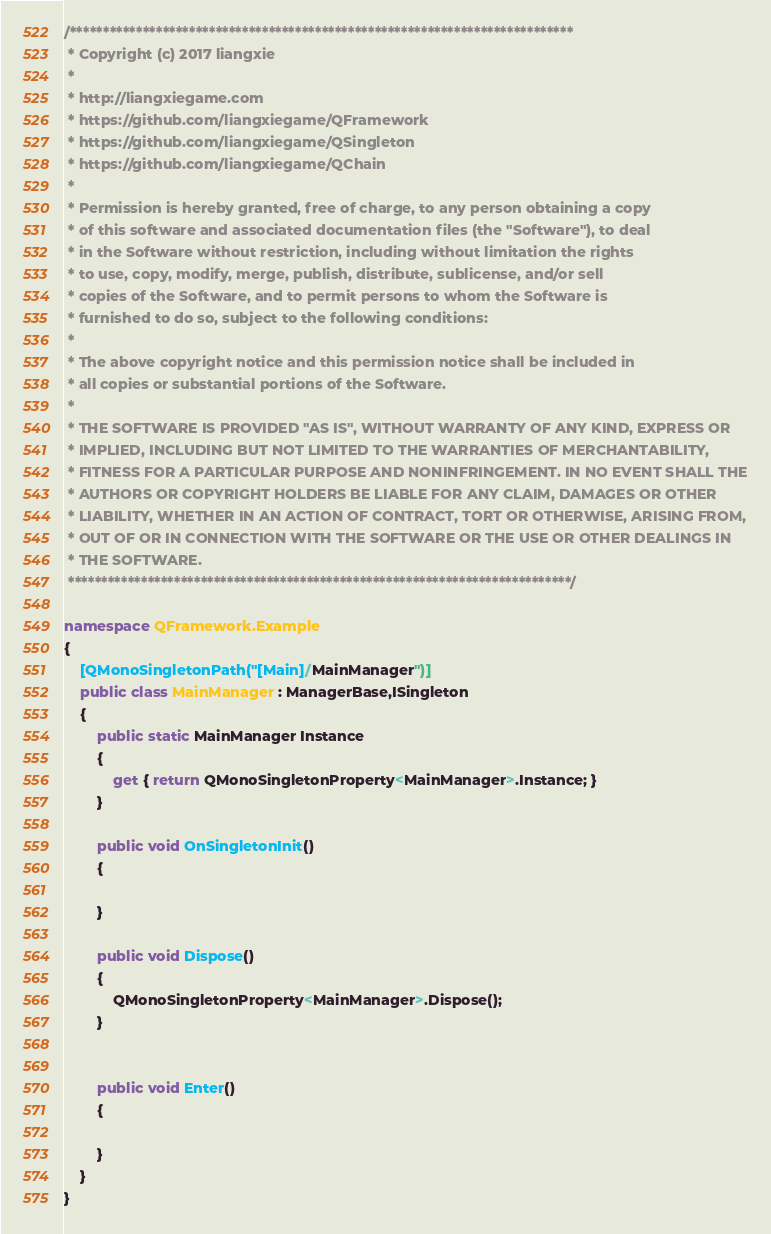Convert code to text. <code><loc_0><loc_0><loc_500><loc_500><_C#_>/****************************************************************************
 * Copyright (c) 2017 liangxie
 * 
 * http://liangxiegame.com
 * https://github.com/liangxiegame/QFramework
 * https://github.com/liangxiegame/QSingleton
 * https://github.com/liangxiegame/QChain
 *
 * Permission is hereby granted, free of charge, to any person obtaining a copy
 * of this software and associated documentation files (the "Software"), to deal
 * in the Software without restriction, including without limitation the rights
 * to use, copy, modify, merge, publish, distribute, sublicense, and/or sell
 * copies of the Software, and to permit persons to whom the Software is
 * furnished to do so, subject to the following conditions:
 * 
 * The above copyright notice and this permission notice shall be included in
 * all copies or substantial portions of the Software.
 * 
 * THE SOFTWARE IS PROVIDED "AS IS", WITHOUT WARRANTY OF ANY KIND, EXPRESS OR
 * IMPLIED, INCLUDING BUT NOT LIMITED TO THE WARRANTIES OF MERCHANTABILITY,
 * FITNESS FOR A PARTICULAR PURPOSE AND NONINFRINGEMENT. IN NO EVENT SHALL THE
 * AUTHORS OR COPYRIGHT HOLDERS BE LIABLE FOR ANY CLAIM, DAMAGES OR OTHER
 * LIABILITY, WHETHER IN AN ACTION OF CONTRACT, TORT OR OTHERWISE, ARISING FROM,
 * OUT OF OR IN CONNECTION WITH THE SOFTWARE OR THE USE OR OTHER DEALINGS IN
 * THE SOFTWARE.
 ****************************************************************************/

namespace QFramework.Example
{	
	[QMonoSingletonPath("[Main]/MainManager")]
	public class MainManager : ManagerBase,ISingleton
	{
		public static MainManager Instance
		{
			get { return QMonoSingletonProperty<MainManager>.Instance; }
		}
		
		public void OnSingletonInit()
		{
			
		}

		public void Dispose()
		{
			QMonoSingletonProperty<MainManager>.Dispose();
		}


		public void Enter()
		{
			
		}
	}
}

</code> 